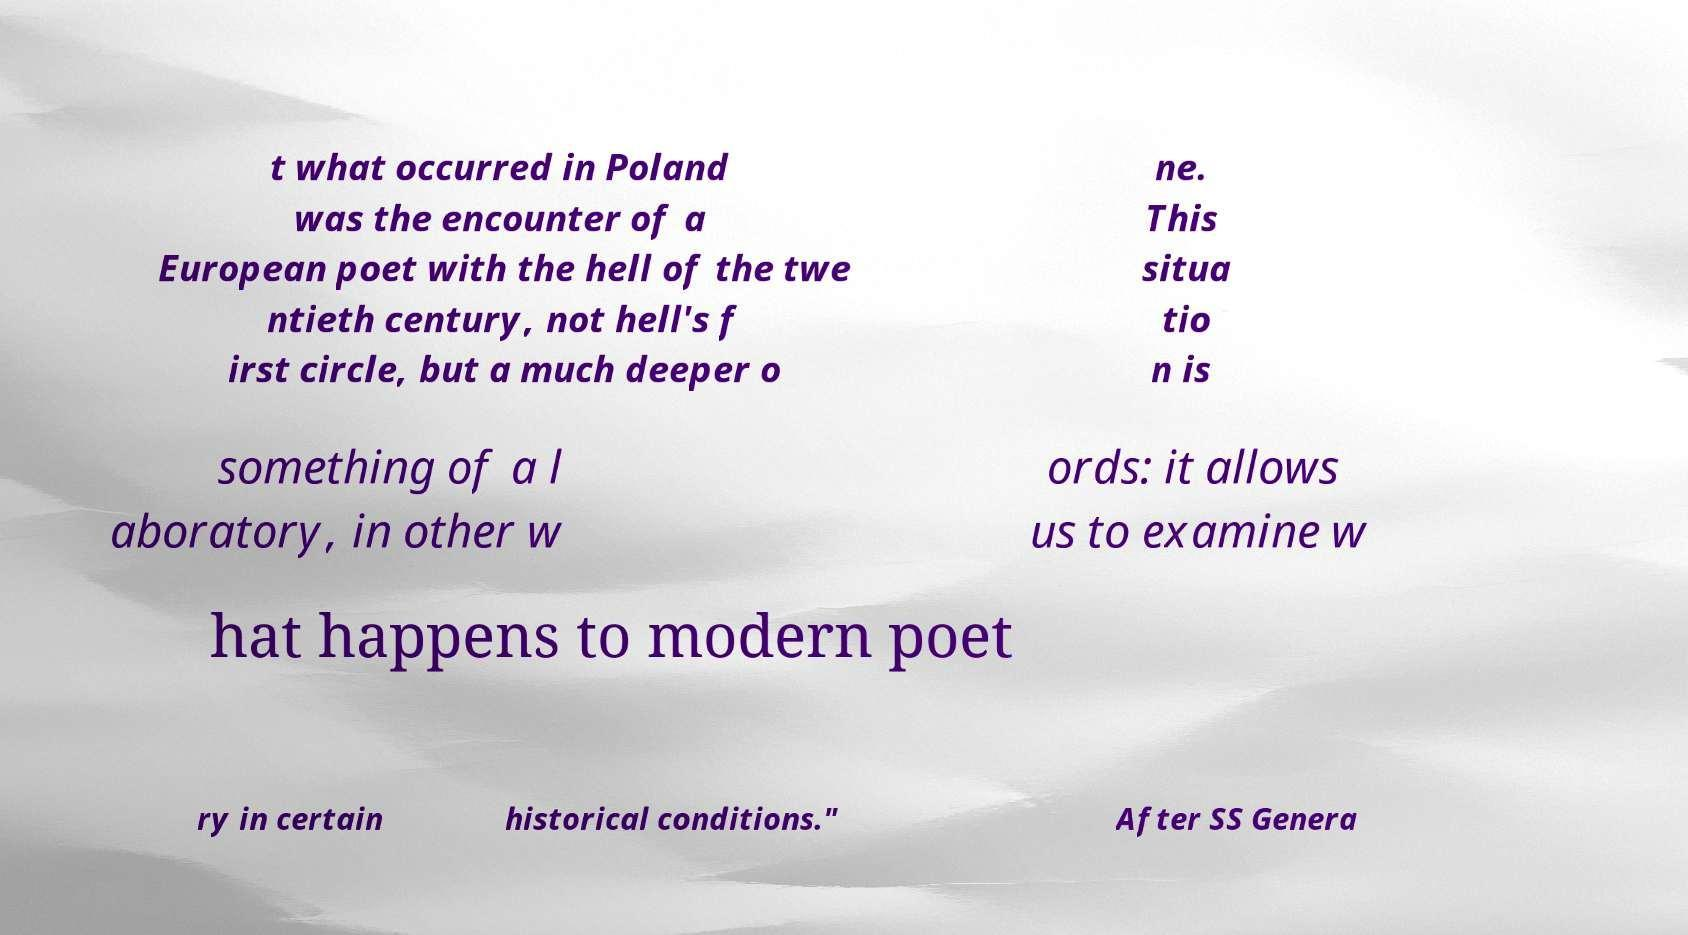I need the written content from this picture converted into text. Can you do that? t what occurred in Poland was the encounter of a European poet with the hell of the twe ntieth century, not hell's f irst circle, but a much deeper o ne. This situa tio n is something of a l aboratory, in other w ords: it allows us to examine w hat happens to modern poet ry in certain historical conditions." After SS Genera 